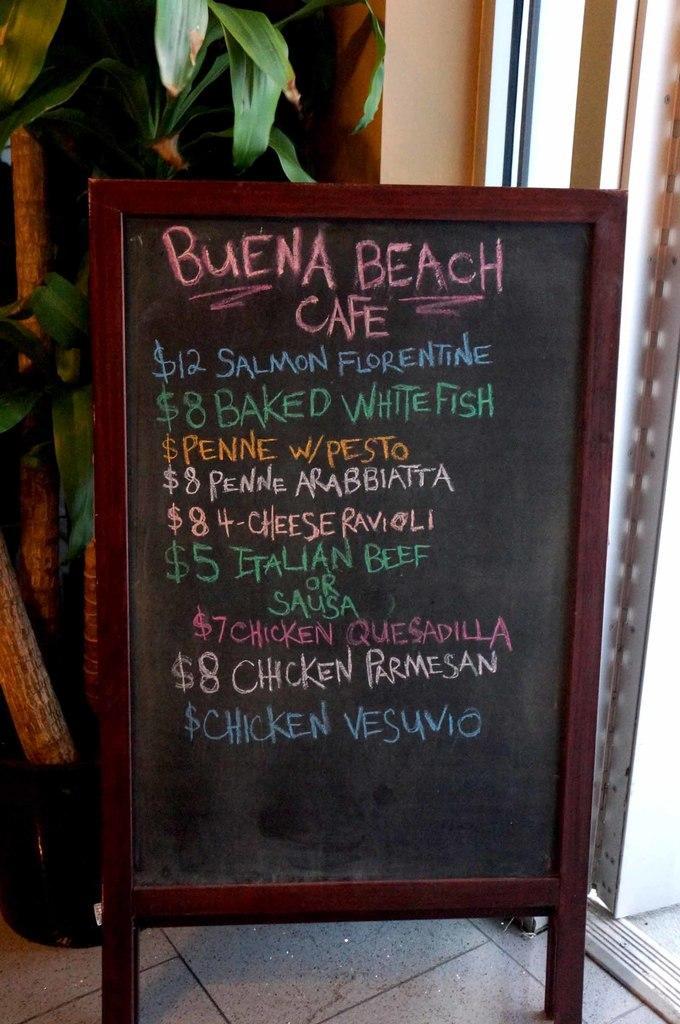Please provide a concise description of this image. There is a price board as we can see in the middle of this image. We can see a plant and a wall in the background. 